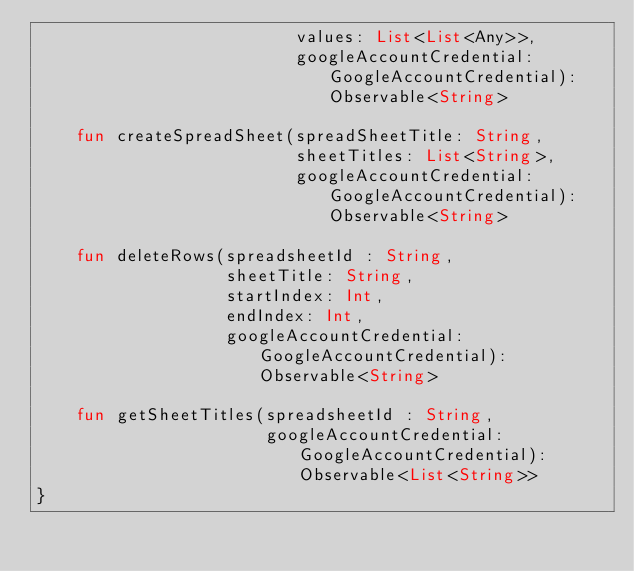Convert code to text. <code><loc_0><loc_0><loc_500><loc_500><_Kotlin_>                          values: List<List<Any>>,
                          googleAccountCredential: GoogleAccountCredential): Observable<String>

    fun createSpreadSheet(spreadSheetTitle: String,
                          sheetTitles: List<String>,
                          googleAccountCredential: GoogleAccountCredential): Observable<String>

    fun deleteRows(spreadsheetId : String,
                   sheetTitle: String,
                   startIndex: Int,
                   endIndex: Int,
                   googleAccountCredential: GoogleAccountCredential): Observable<String>

    fun getSheetTitles(spreadsheetId : String,
                       googleAccountCredential: GoogleAccountCredential): Observable<List<String>>
}</code> 